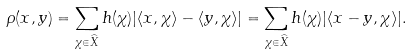<formula> <loc_0><loc_0><loc_500><loc_500>\rho ( x , y ) = \sum _ { \chi \in \widehat { X } } h ( \chi ) | \langle x , \chi \rangle - \langle y , \chi \rangle | = \sum _ { \chi \in \widehat { X } } h ( \chi ) | \langle x - y , \chi \rangle | .</formula> 